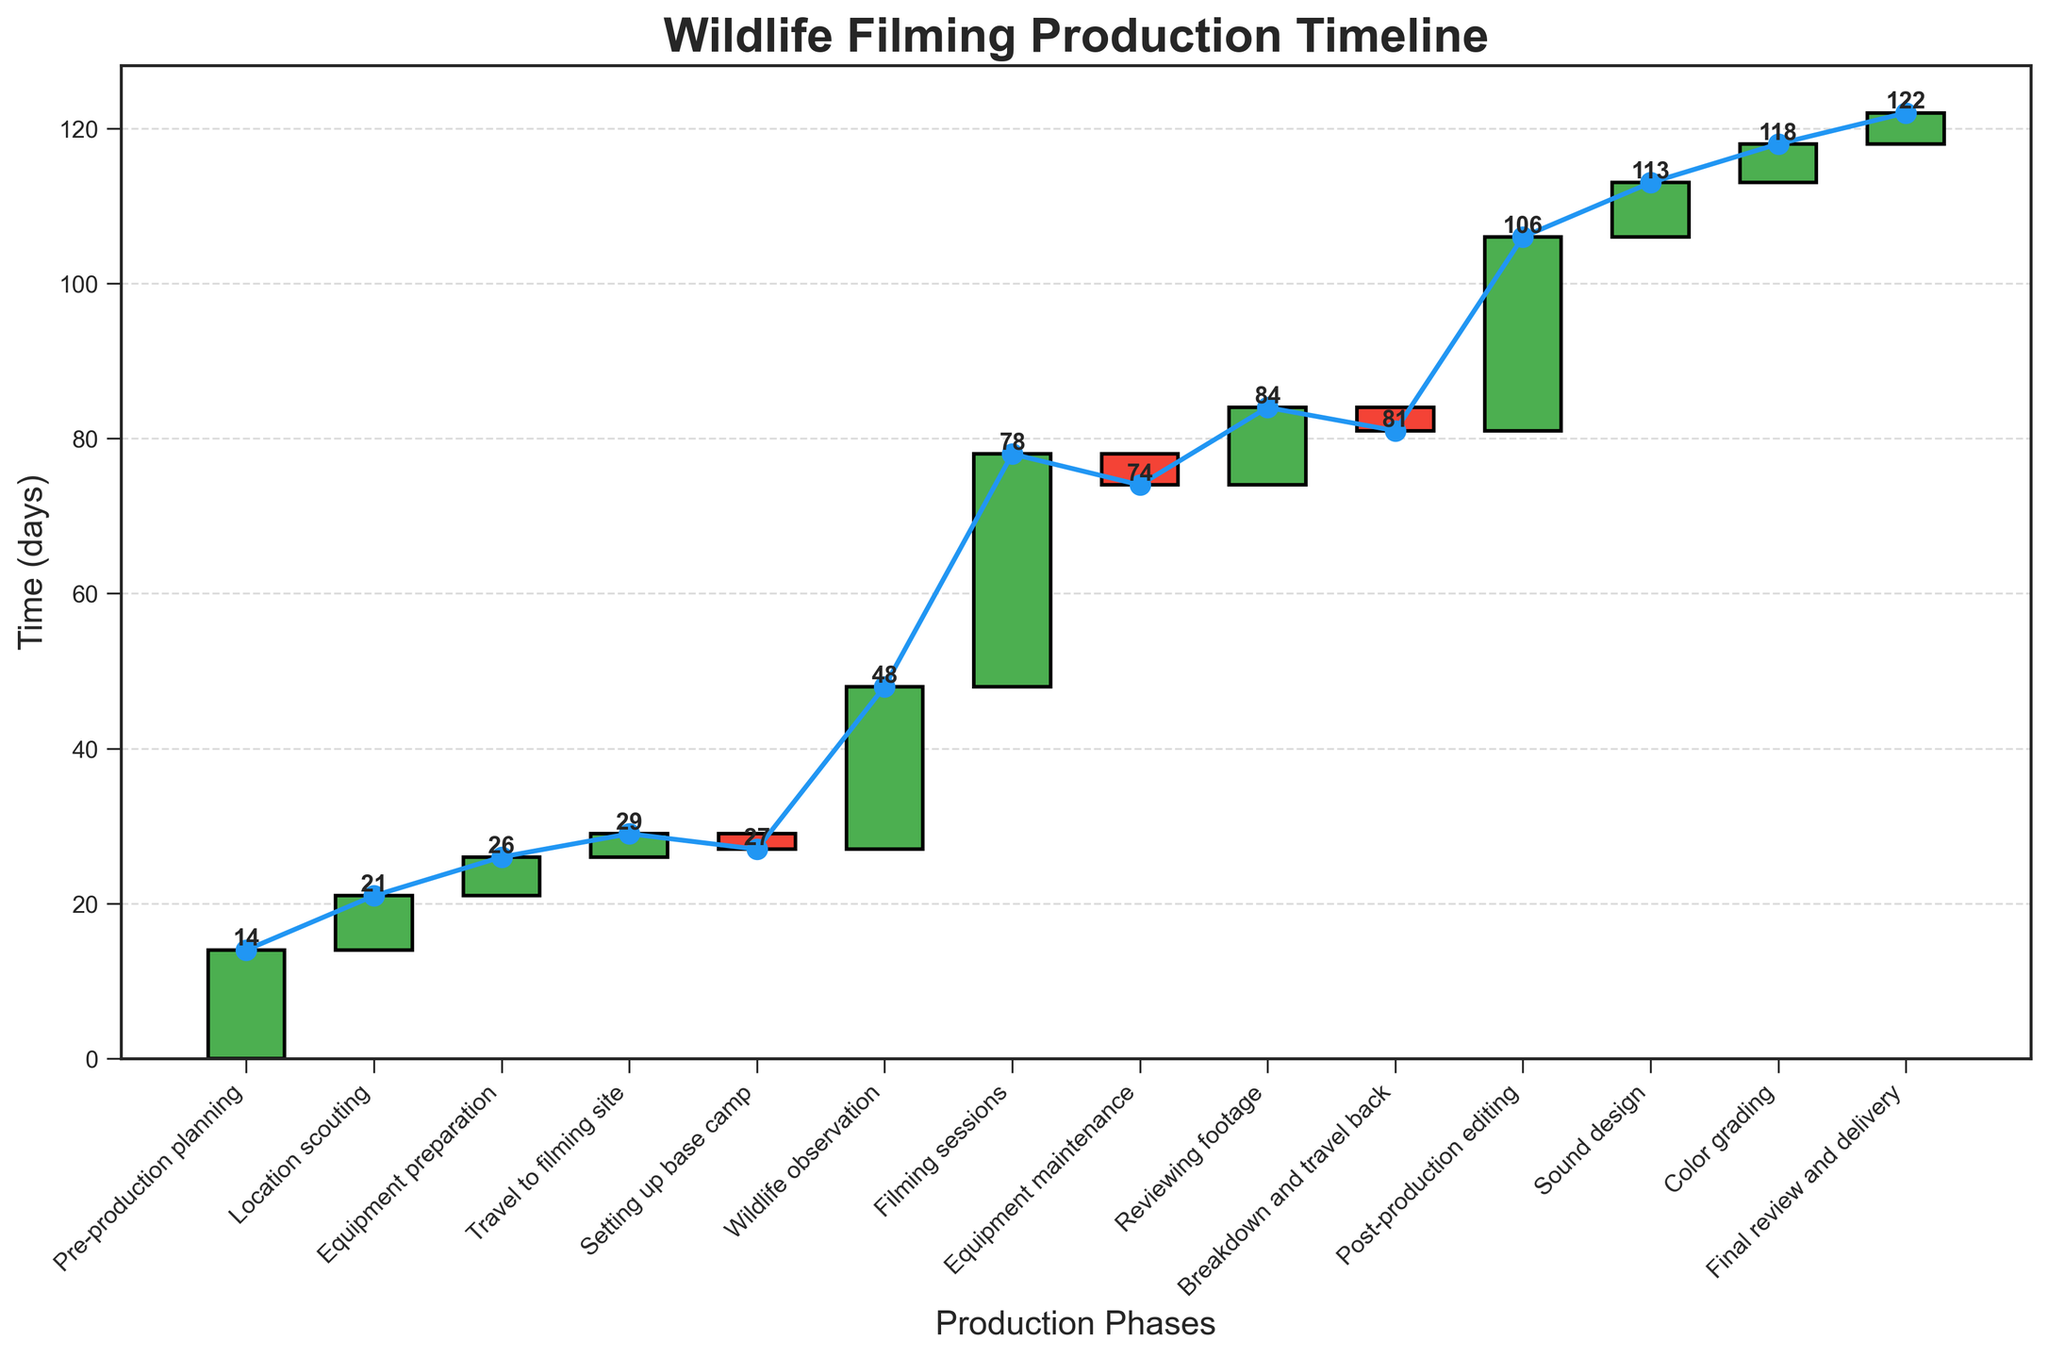What is the title of the chart? The title of the chart is prominently displayed at the top.
Answer: Wildlife Filming Production Timeline How many phases are included in the production timeline? Each phase is represented by a bar on the chart. By counting them, we can determine the total number of phases.
Answer: 14 Which phase takes the most time? The phase with the highest positive bar indicates the phase that takes the longest time.
Answer: Filming sessions What is the cumulative time spent by the end of "Wildlife observation"? To get the cumulative time, sum the values of all the phases up to and including "Wildlife observation".
Answer: 48 days What is the total time spent in negative phases? Identify the phases with negative bars and sum their times. These phases are: "Setting up base camp", "Equipment maintenance", and "Breakdown and travel back". The sum is -2 + -4 + -3.
Answer: -9 days How much more time is spent in "Post-production editing" compared to "Pre-production planning"? Subtract the time spent in "Pre-production planning" from the time spent in "Post-production editing".
Answer: 11 days Which phase follows "Travel to filming site"? Identify the phase that comes immediately after "Travel to filming site" on the x-axis.
Answer: Setting up base camp What is the average time spent on the phases "Color grading" and "Final review and delivery"? Add the times spent on "Color grading" and "Final review and delivery", then divide by 2 to get the average.
Answer: 4.5 days Which phase has a cumulative time of exactly 74 days? The cumulative times are indicated by the line graph. Find the phase that corresponds to a cumulative time of 74 days.
Answer: Post-production editing Is the cumulative time spent increasing or decreasing over time? Observe the direction of the cumulative line graph. Since it generally trends upwards, we can conclude it is increasing.
Answer: Increasing 